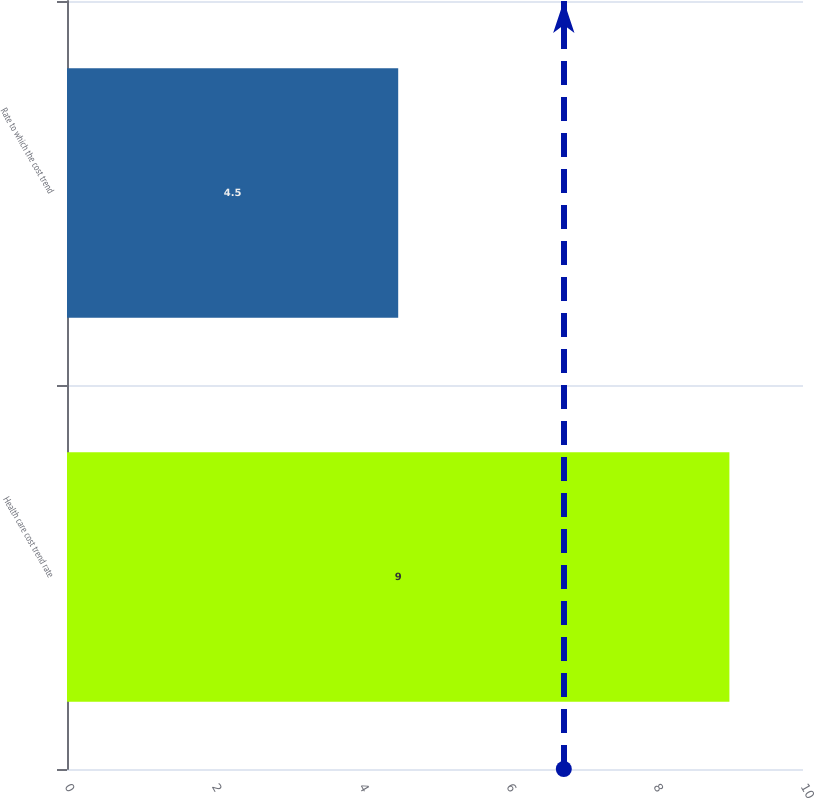Convert chart to OTSL. <chart><loc_0><loc_0><loc_500><loc_500><bar_chart><fcel>Health care cost trend rate<fcel>Rate to which the cost trend<nl><fcel>9<fcel>4.5<nl></chart> 